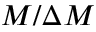Convert formula to latex. <formula><loc_0><loc_0><loc_500><loc_500>M / \Delta M</formula> 